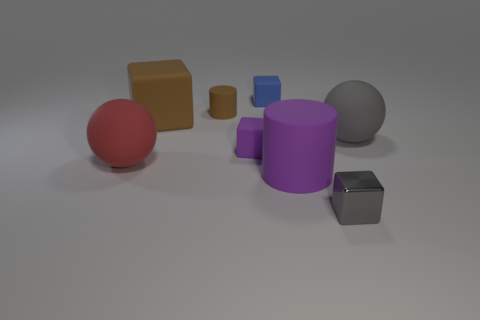Add 1 matte cylinders. How many objects exist? 9 Subtract all spheres. How many objects are left? 6 Subtract all rubber cylinders. Subtract all brown cubes. How many objects are left? 5 Add 4 brown cylinders. How many brown cylinders are left? 5 Add 7 balls. How many balls exist? 9 Subtract 0 purple balls. How many objects are left? 8 